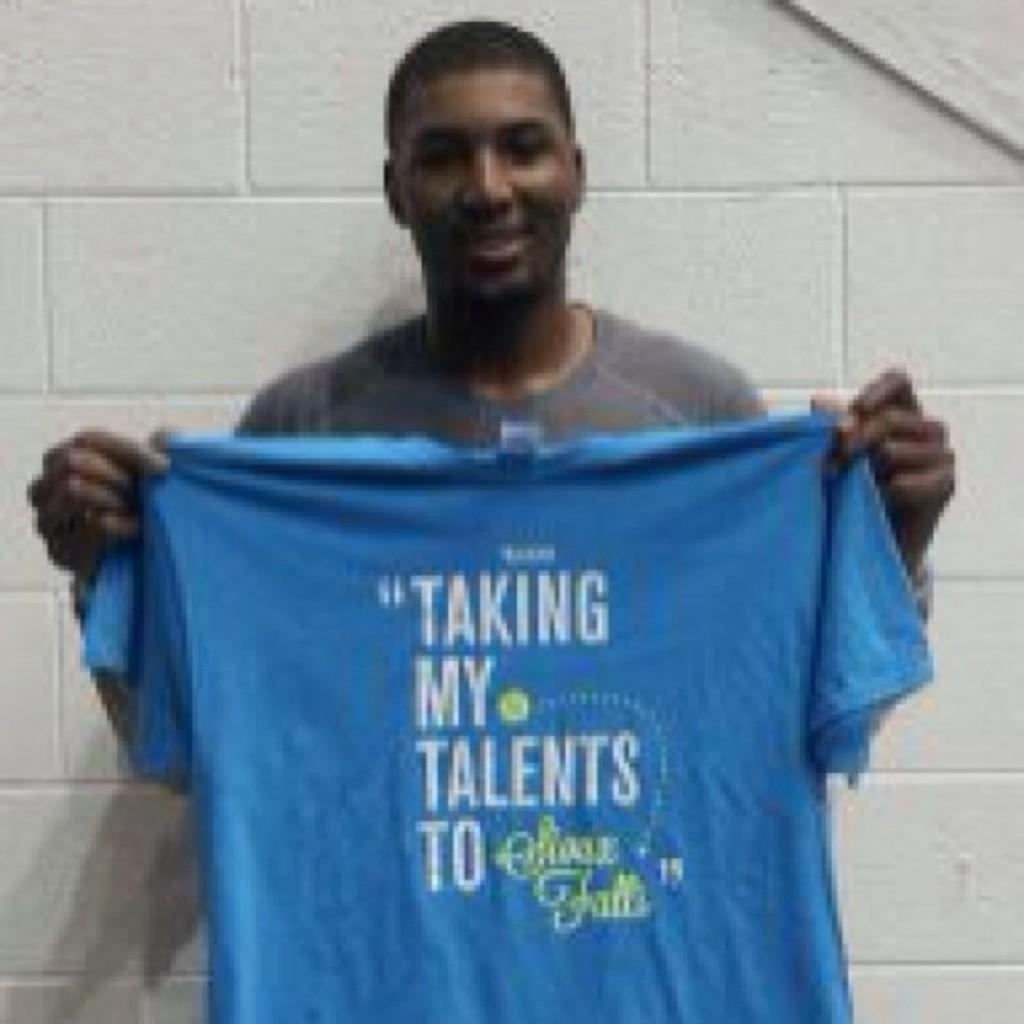Who is present in the image? There is a man in the image. What is the man holding in his hands? The man is holding a t-shirt in his hands. What can be seen in the background of the image? There is a wall in the background of the image. What type of wall is depicted in the image? The provided facts do not specify the type of wall, only that there is a wall in the background. --- Facts: 1. There is a car in the image. 2. The car is parked on the street. 3. There are trees on both sides of the street. 4. The sky is visible in the image. Absurd Topics: parade, bicycle, ocean Conversation: What is the main subject of the image? The main subject of the image is a car. Where is the car located in the image? The car is parked on the street. What can be seen on both sides of the street in the image? There are trees on both sides of the street. What is visible in the background of the image? The sky is visible in the image. Reasoning: Let's think step by step in order to produce the conversation. We start by identifying the main subject in the image, which is the car. Then, we describe the location of the car, which is parked on the street. Next, we mention the surrounding environment, which includes trees on both sides of the street. Finally, we describe the background of the image, which is the sky. Each question is designed to elicit a specific detail about the image that is known from the provided facts. Absurd Question/Answer: Can you see a parade passing by in the image? There is no indication of a parade or any related activities in the image. Is there an ocean visible in the background of the image? The provided facts do not mention an ocean or any water body in the image 